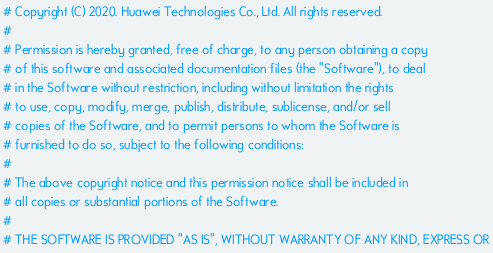Convert code to text. <code><loc_0><loc_0><loc_500><loc_500><_Python_># Copyright (C) 2020. Huawei Technologies Co., Ltd. All rights reserved.
#
# Permission is hereby granted, free of charge, to any person obtaining a copy
# of this software and associated documentation files (the "Software"), to deal
# in the Software without restriction, including without limitation the rights
# to use, copy, modify, merge, publish, distribute, sublicense, and/or sell
# copies of the Software, and to permit persons to whom the Software is
# furnished to do so, subject to the following conditions:
#
# The above copyright notice and this permission notice shall be included in
# all copies or substantial portions of the Software.
#
# THE SOFTWARE IS PROVIDED "AS IS", WITHOUT WARRANTY OF ANY KIND, EXPRESS OR</code> 